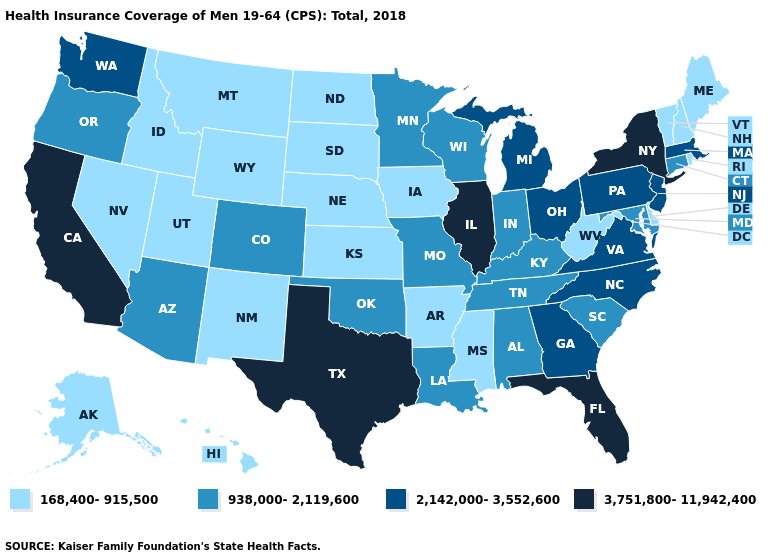Does Nebraska have the same value as Virginia?
Short answer required. No. What is the value of Alabama?
Keep it brief. 938,000-2,119,600. How many symbols are there in the legend?
Keep it brief. 4. Does New Hampshire have the lowest value in the Northeast?
Write a very short answer. Yes. What is the value of Kansas?
Quick response, please. 168,400-915,500. Name the states that have a value in the range 3,751,800-11,942,400?
Give a very brief answer. California, Florida, Illinois, New York, Texas. What is the lowest value in the West?
Concise answer only. 168,400-915,500. Which states hav the highest value in the West?
Give a very brief answer. California. Name the states that have a value in the range 2,142,000-3,552,600?
Concise answer only. Georgia, Massachusetts, Michigan, New Jersey, North Carolina, Ohio, Pennsylvania, Virginia, Washington. What is the value of South Dakota?
Quick response, please. 168,400-915,500. What is the value of Connecticut?
Short answer required. 938,000-2,119,600. Name the states that have a value in the range 938,000-2,119,600?
Keep it brief. Alabama, Arizona, Colorado, Connecticut, Indiana, Kentucky, Louisiana, Maryland, Minnesota, Missouri, Oklahoma, Oregon, South Carolina, Tennessee, Wisconsin. What is the value of Maine?
Keep it brief. 168,400-915,500. What is the lowest value in the USA?
Quick response, please. 168,400-915,500. Among the states that border Iowa , does Missouri have the highest value?
Answer briefly. No. 